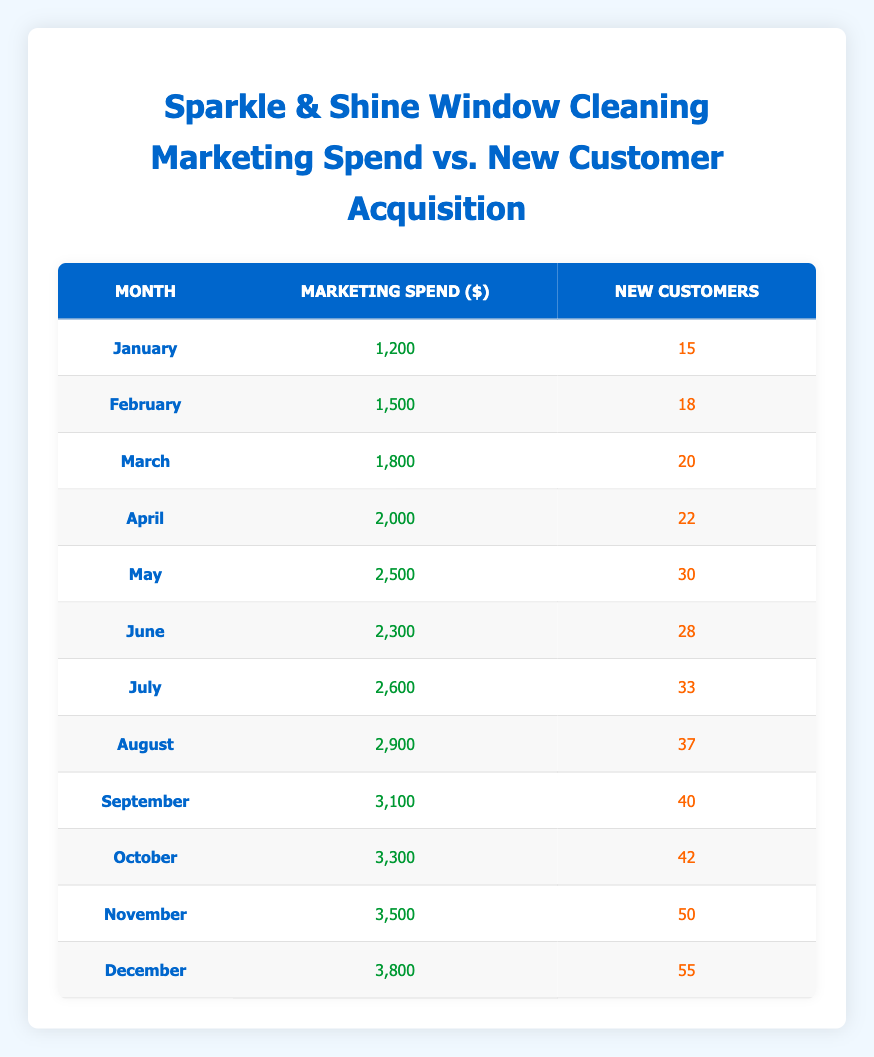What was the marketing spend in December? The table shows the marketing spend for each month. In December, the marketing spend is listed as 3,800 dollars.
Answer: 3,800 How many new customers were acquired in May? Referring to the table, in May, the new customer acquisition is recorded as 30 customers.
Answer: 30 What is the difference in marketing spend between March and April? In March, the marketing spend is 1,800 dollars and in April, it is 2,000 dollars. The difference is calculated as 2,000 - 1,800, which equals 200 dollars.
Answer: 200 Is the new customer acquisition rate in October higher than in January? By comparing the values in the table, October has an acquisition rate of 42 customers and January has 15 customers. Since 42 is greater than 15, the statement is true.
Answer: Yes What is the total marketing spend from January to June? The marketing spend from January to June includes the following amounts: 1,200 + 1,500 + 1,800 + 2,000 + 2,500 + 2,300. Adding these gives: 1,200 + 1,500 + 1,800 + 2,000 + 2,500 + 2,300 = 11,300 dollars.
Answer: 11,300 How many new customers were acquired in August compared to July? In August, the new customer acquisition is 37, while in July it is 33. Comparing these, 37 is greater than 33 thus August saw more new customers acquired. The difference is calculated as 37 - 33 = 4.
Answer: 4 What is the average number of new customers acquired from January to December? To find the average, we must add all new customer acquisitions for the months from January (15) to December (55), which totals to 15 + 18 + 20 + 22 + 30 + 28 + 33 + 37 + 40 + 42 + 50 + 55 =  435. We then divide by the number of months, which is 12: 435 / 12 = 36.25.
Answer: 36.25 Was there an increase in new customer acquisition from November to December? November has an acquisition rate of 50 customers and December has 55 customers. Since 55 is greater than 50, it can be concluded that there was indeed an increase.
Answer: Yes What was the highest marketing spend in any month throughout the year? Looking at the table, the marketing spend is highest in December at 3,800 dollars.
Answer: 3,800 